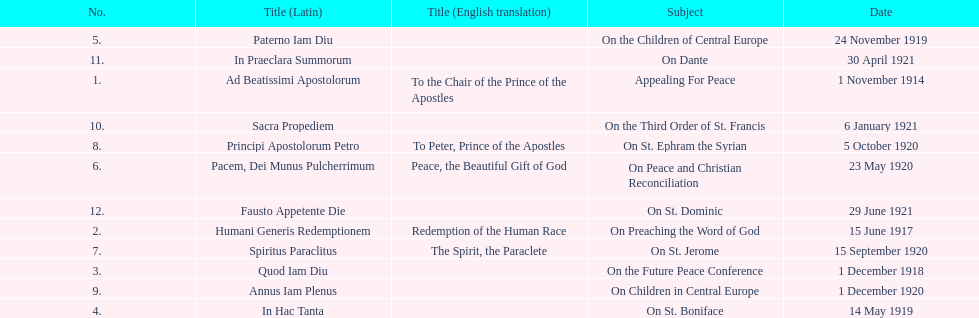After 1 december 1918, when was the next papal letter? 14 May 1919. 